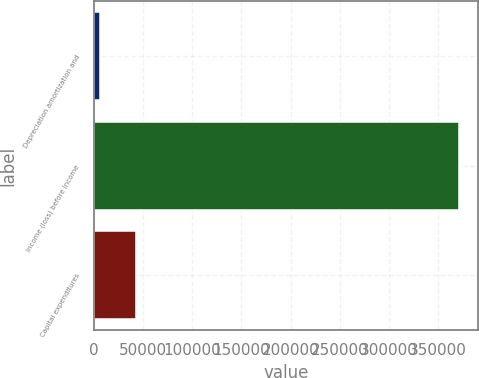Convert chart. <chart><loc_0><loc_0><loc_500><loc_500><bar_chart><fcel>Depreciation amortization and<fcel>Income (loss) before income<fcel>Capital expenditures<nl><fcel>6274<fcel>372039<fcel>42850.5<nl></chart> 